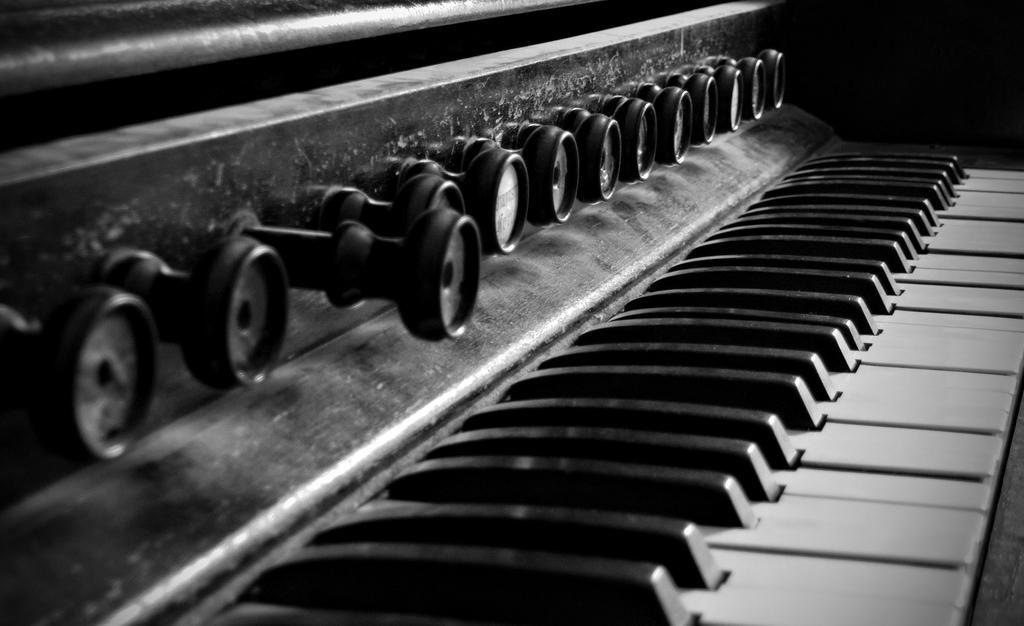How would you summarize this image in a sentence or two? This is a musical instrument. 